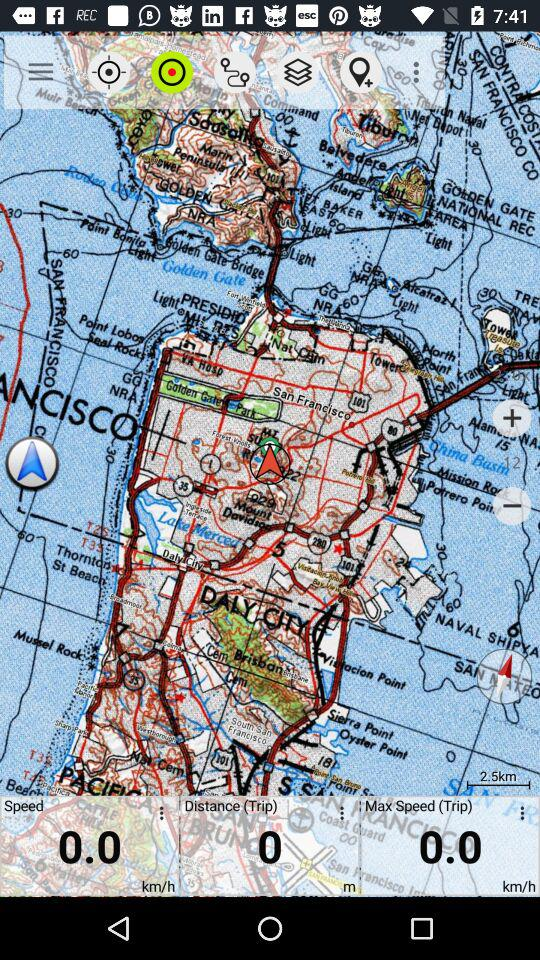What is the unit of speed? The unit of speed is kilometers per hour. 